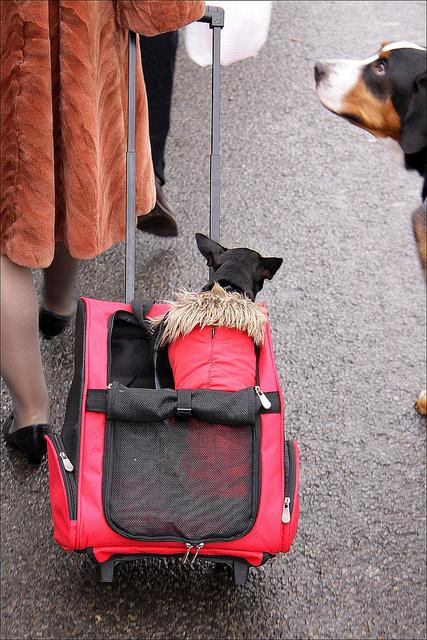What type of shoes does the woman have on?

Choices:
A) boots
B) sneakers
C) high heels
D) sandals high heels 